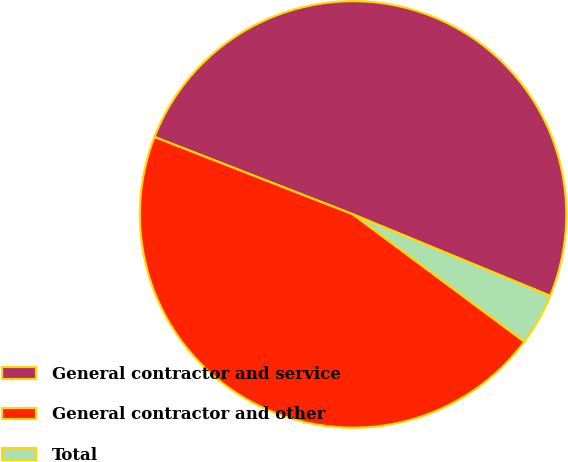Convert chart. <chart><loc_0><loc_0><loc_500><loc_500><pie_chart><fcel>General contractor and service<fcel>General contractor and other<fcel>Total<nl><fcel>50.32%<fcel>45.75%<fcel>3.93%<nl></chart> 